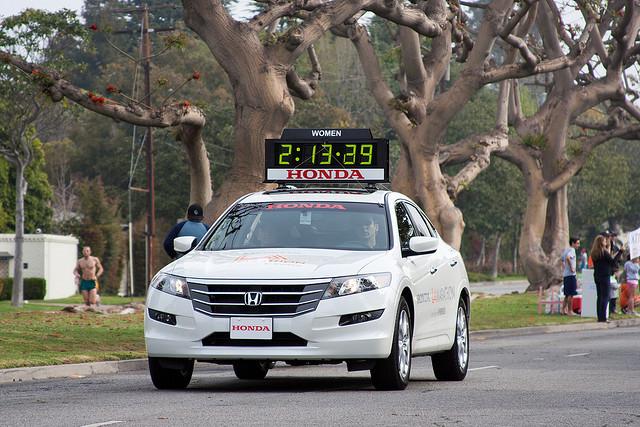What dealership is this car from?
Keep it brief. Honda. What color is the car?
Answer briefly. White. What time does the clock say?
Be succinct. 2:13:39. 